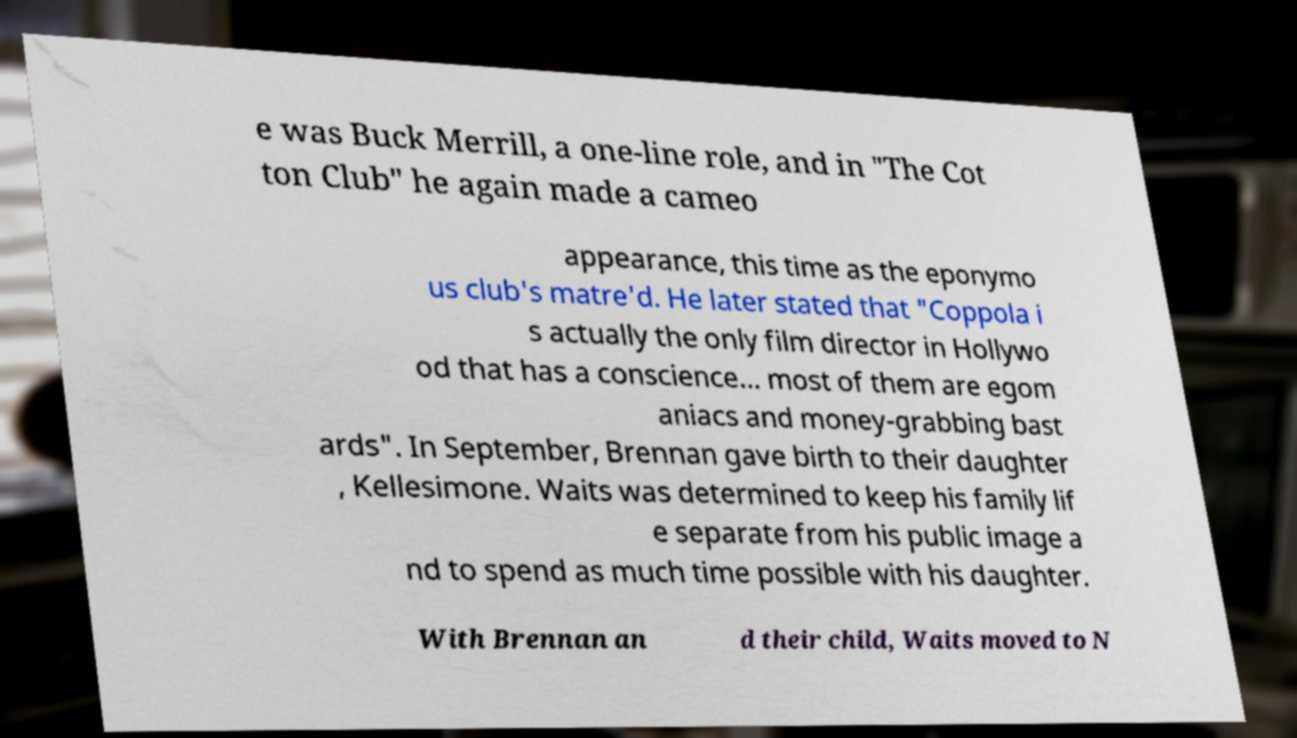Please identify and transcribe the text found in this image. e was Buck Merrill, a one-line role, and in "The Cot ton Club" he again made a cameo appearance, this time as the eponymo us club's matre'd. He later stated that "Coppola i s actually the only film director in Hollywo od that has a conscience... most of them are egom aniacs and money-grabbing bast ards". In September, Brennan gave birth to their daughter , Kellesimone. Waits was determined to keep his family lif e separate from his public image a nd to spend as much time possible with his daughter. With Brennan an d their child, Waits moved to N 